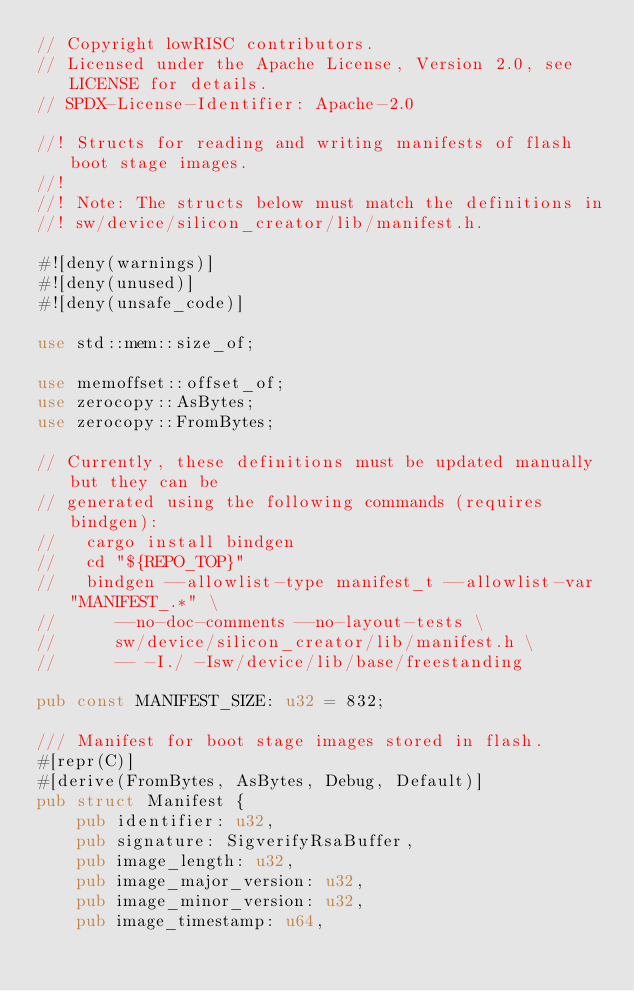<code> <loc_0><loc_0><loc_500><loc_500><_Rust_>// Copyright lowRISC contributors.
// Licensed under the Apache License, Version 2.0, see LICENSE for details.
// SPDX-License-Identifier: Apache-2.0

//! Structs for reading and writing manifests of flash boot stage images.
//!
//! Note: The structs below must match the definitions in
//! sw/device/silicon_creator/lib/manifest.h.

#![deny(warnings)]
#![deny(unused)]
#![deny(unsafe_code)]

use std::mem::size_of;

use memoffset::offset_of;
use zerocopy::AsBytes;
use zerocopy::FromBytes;

// Currently, these definitions must be updated manually but they can be
// generated using the following commands (requires bindgen):
//   cargo install bindgen
//   cd "${REPO_TOP}"
//   bindgen --allowlist-type manifest_t --allowlist-var "MANIFEST_.*" \
//      --no-doc-comments --no-layout-tests \
//      sw/device/silicon_creator/lib/manifest.h \
//      -- -I./ -Isw/device/lib/base/freestanding

pub const MANIFEST_SIZE: u32 = 832;

/// Manifest for boot stage images stored in flash.
#[repr(C)]
#[derive(FromBytes, AsBytes, Debug, Default)]
pub struct Manifest {
    pub identifier: u32,
    pub signature: SigverifyRsaBuffer,
    pub image_length: u32,
    pub image_major_version: u32,
    pub image_minor_version: u32,
    pub image_timestamp: u64,</code> 